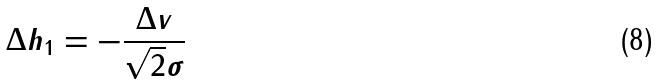Convert formula to latex. <formula><loc_0><loc_0><loc_500><loc_500>\Delta h _ { 1 } = - \frac { \Delta v } { \sqrt { 2 } \sigma }</formula> 